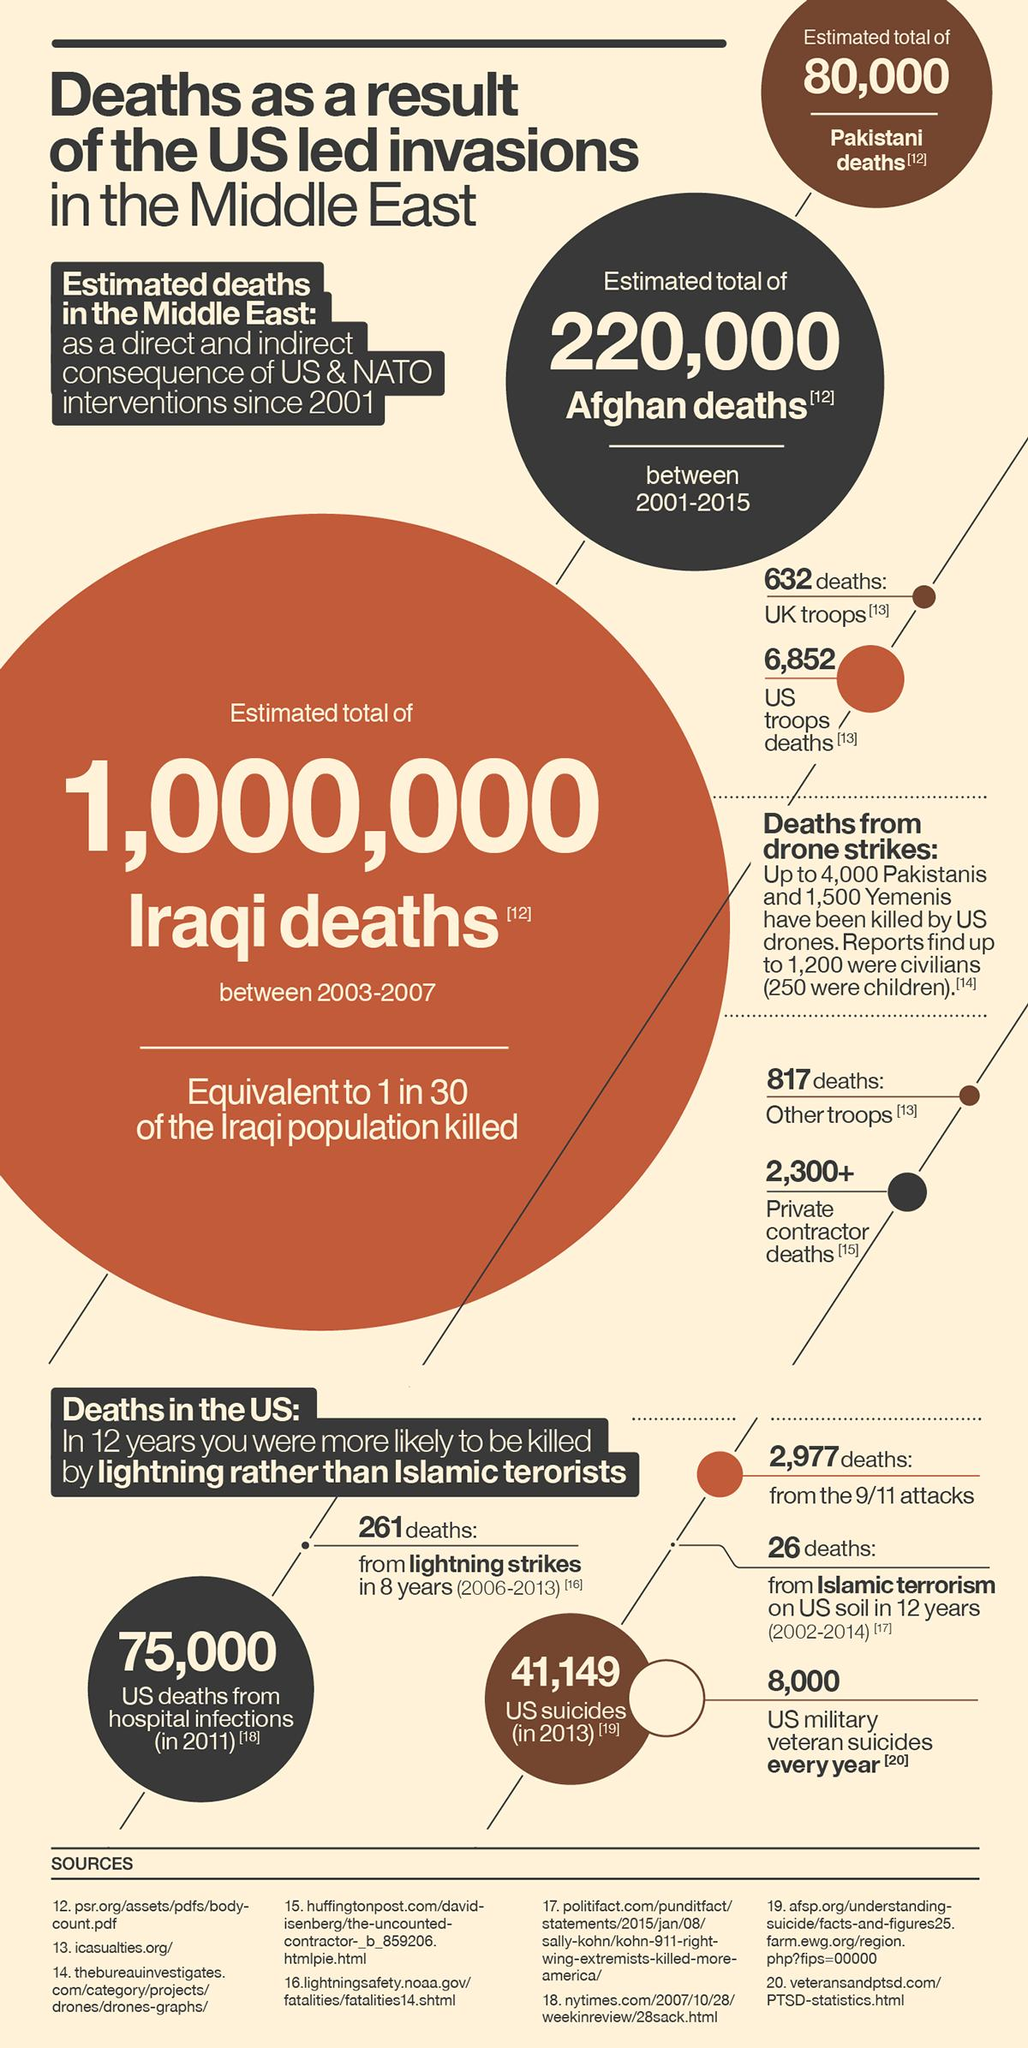Give some essential details in this illustration. In the United States, 261 people lost their lives due to lightning strikes in the past year. 